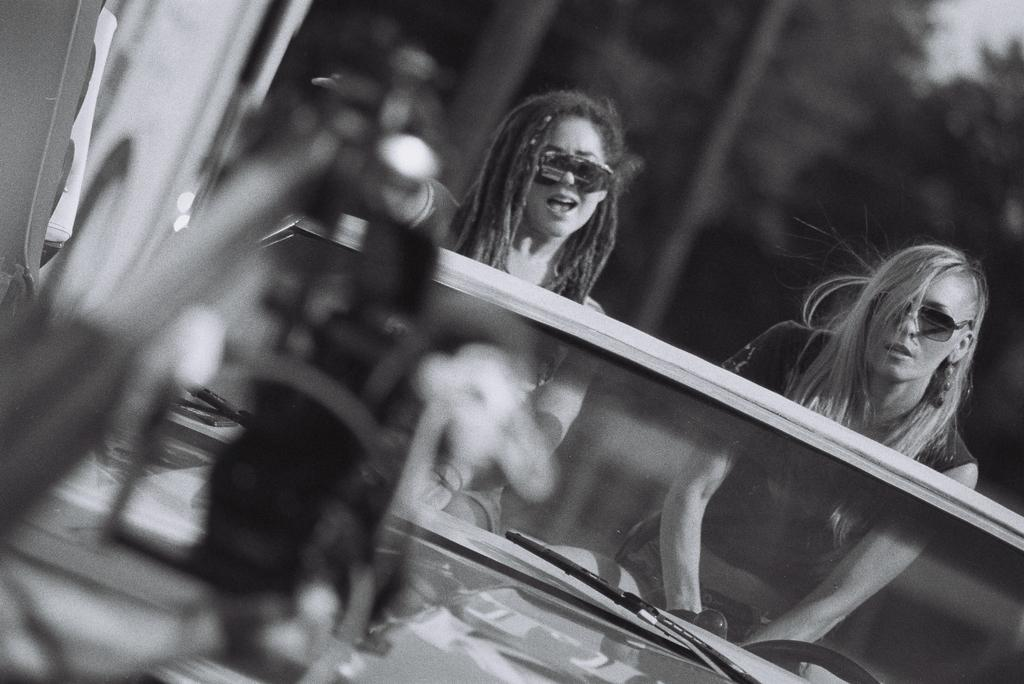How many people are in the car in the image? There are two women in the car. What feature is present on the car to help with visibility during rain or snow? The car has a wiper. What is used to control the direction of the car? The car has a steering wheel. What can be seen in the background of the image? There are trees in the background of the image. What is the color scheme of the image? The image is black and white. What type of celery is being used as a prop in the image? There is no celery present in the image. Can you tell me the name of the judge sitting in the car with the women? There is no judge present in the image; it only features two women in a car. 